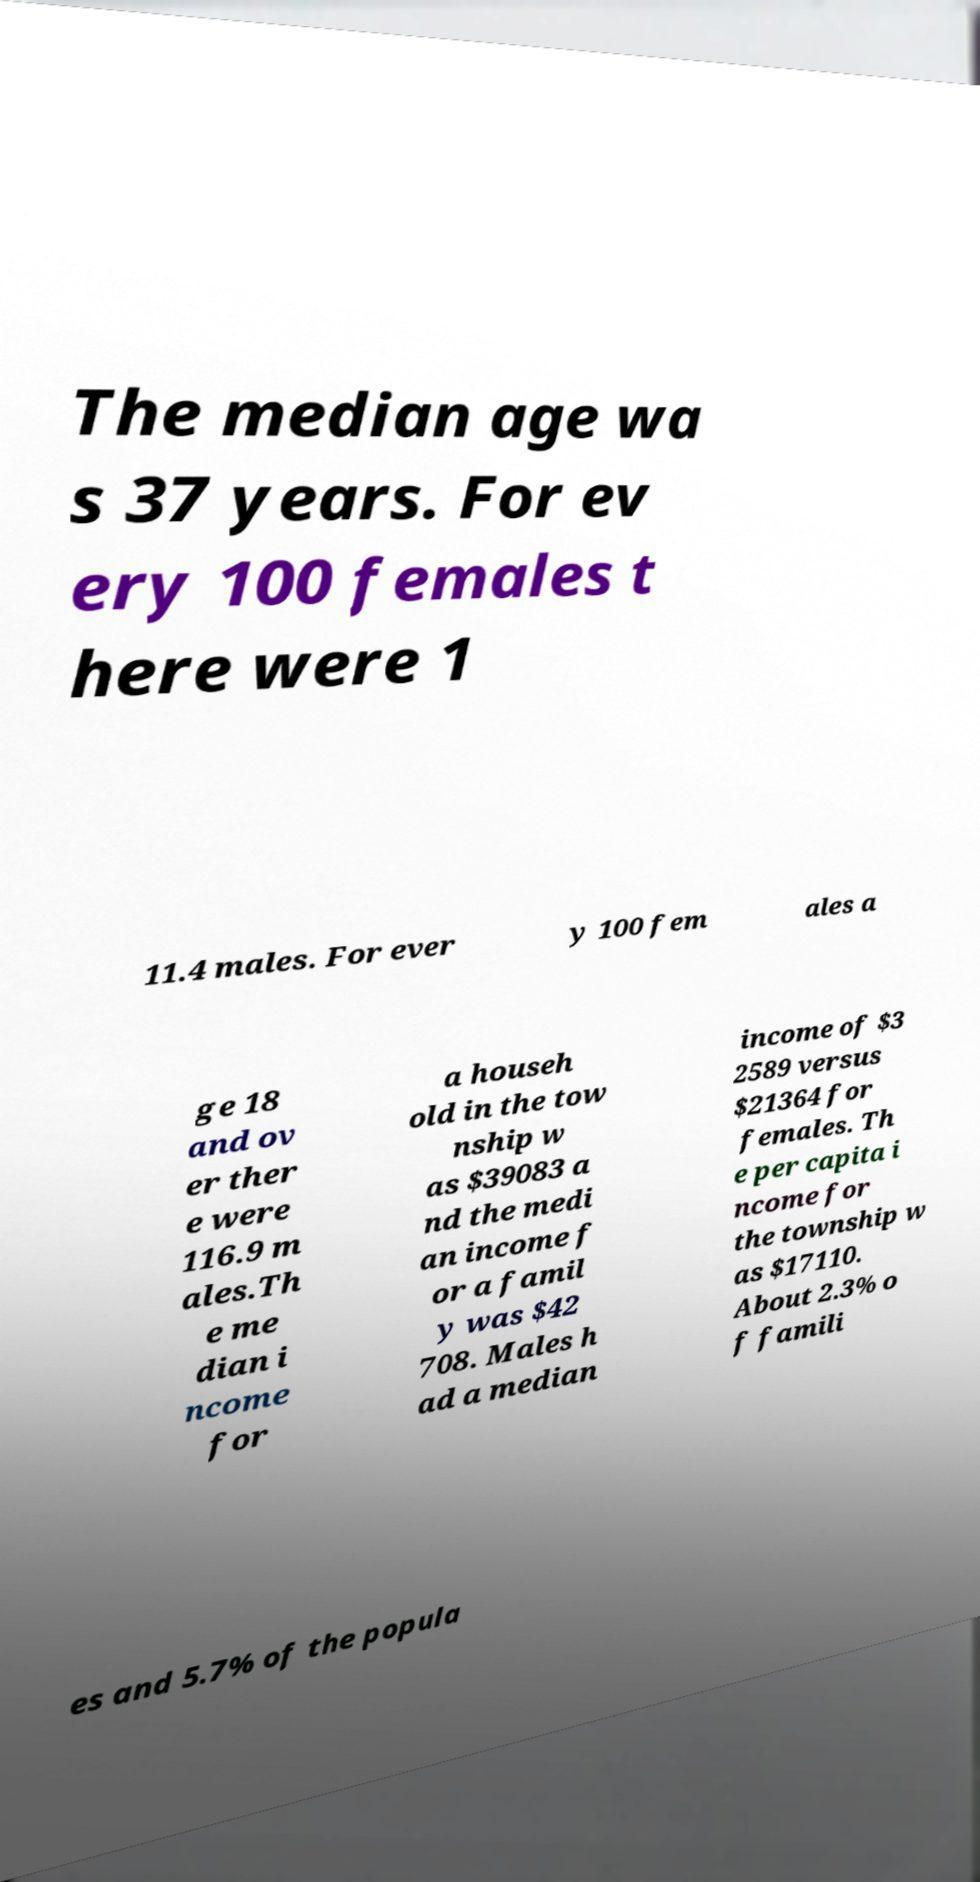Could you extract and type out the text from this image? The median age wa s 37 years. For ev ery 100 females t here were 1 11.4 males. For ever y 100 fem ales a ge 18 and ov er ther e were 116.9 m ales.Th e me dian i ncome for a househ old in the tow nship w as $39083 a nd the medi an income f or a famil y was $42 708. Males h ad a median income of $3 2589 versus $21364 for females. Th e per capita i ncome for the township w as $17110. About 2.3% o f famili es and 5.7% of the popula 